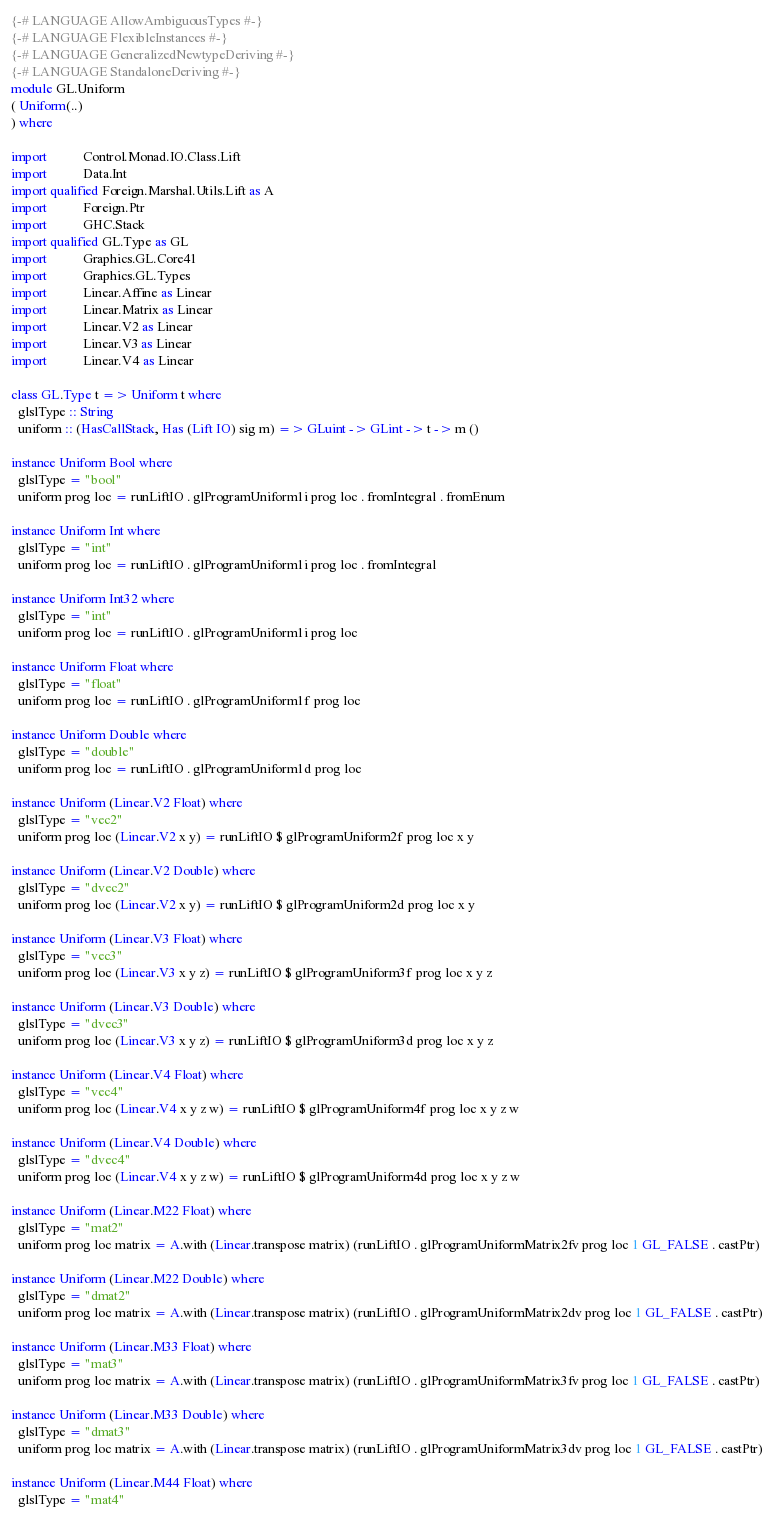Convert code to text. <code><loc_0><loc_0><loc_500><loc_500><_Haskell_>{-# LANGUAGE AllowAmbiguousTypes #-}
{-# LANGUAGE FlexibleInstances #-}
{-# LANGUAGE GeneralizedNewtypeDeriving #-}
{-# LANGUAGE StandaloneDeriving #-}
module GL.Uniform
( Uniform(..)
) where

import           Control.Monad.IO.Class.Lift
import           Data.Int
import qualified Foreign.Marshal.Utils.Lift as A
import           Foreign.Ptr
import           GHC.Stack
import qualified GL.Type as GL
import           Graphics.GL.Core41
import           Graphics.GL.Types
import           Linear.Affine as Linear
import           Linear.Matrix as Linear
import           Linear.V2 as Linear
import           Linear.V3 as Linear
import           Linear.V4 as Linear

class GL.Type t => Uniform t where
  glslType :: String
  uniform :: (HasCallStack, Has (Lift IO) sig m) => GLuint -> GLint -> t -> m ()

instance Uniform Bool where
  glslType = "bool"
  uniform prog loc = runLiftIO . glProgramUniform1i prog loc . fromIntegral . fromEnum

instance Uniform Int where
  glslType = "int"
  uniform prog loc = runLiftIO . glProgramUniform1i prog loc . fromIntegral

instance Uniform Int32 where
  glslType = "int"
  uniform prog loc = runLiftIO . glProgramUniform1i prog loc

instance Uniform Float where
  glslType = "float"
  uniform prog loc = runLiftIO . glProgramUniform1f prog loc

instance Uniform Double where
  glslType = "double"
  uniform prog loc = runLiftIO . glProgramUniform1d prog loc

instance Uniform (Linear.V2 Float) where
  glslType = "vec2"
  uniform prog loc (Linear.V2 x y) = runLiftIO $ glProgramUniform2f prog loc x y

instance Uniform (Linear.V2 Double) where
  glslType = "dvec2"
  uniform prog loc (Linear.V2 x y) = runLiftIO $ glProgramUniform2d prog loc x y

instance Uniform (Linear.V3 Float) where
  glslType = "vec3"
  uniform prog loc (Linear.V3 x y z) = runLiftIO $ glProgramUniform3f prog loc x y z

instance Uniform (Linear.V3 Double) where
  glslType = "dvec3"
  uniform prog loc (Linear.V3 x y z) = runLiftIO $ glProgramUniform3d prog loc x y z

instance Uniform (Linear.V4 Float) where
  glslType = "vec4"
  uniform prog loc (Linear.V4 x y z w) = runLiftIO $ glProgramUniform4f prog loc x y z w

instance Uniform (Linear.V4 Double) where
  glslType = "dvec4"
  uniform prog loc (Linear.V4 x y z w) = runLiftIO $ glProgramUniform4d prog loc x y z w

instance Uniform (Linear.M22 Float) where
  glslType = "mat2"
  uniform prog loc matrix = A.with (Linear.transpose matrix) (runLiftIO . glProgramUniformMatrix2fv prog loc 1 GL_FALSE . castPtr)

instance Uniform (Linear.M22 Double) where
  glslType = "dmat2"
  uniform prog loc matrix = A.with (Linear.transpose matrix) (runLiftIO . glProgramUniformMatrix2dv prog loc 1 GL_FALSE . castPtr)

instance Uniform (Linear.M33 Float) where
  glslType = "mat3"
  uniform prog loc matrix = A.with (Linear.transpose matrix) (runLiftIO . glProgramUniformMatrix3fv prog loc 1 GL_FALSE . castPtr)

instance Uniform (Linear.M33 Double) where
  glslType = "dmat3"
  uniform prog loc matrix = A.with (Linear.transpose matrix) (runLiftIO . glProgramUniformMatrix3dv prog loc 1 GL_FALSE . castPtr)

instance Uniform (Linear.M44 Float) where
  glslType = "mat4"</code> 